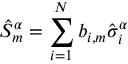Convert formula to latex. <formula><loc_0><loc_0><loc_500><loc_500>\hat { S } _ { m } ^ { \alpha } = \sum _ { i = 1 } ^ { N } b _ { i , m } \hat { \sigma } _ { i } ^ { \alpha }</formula> 